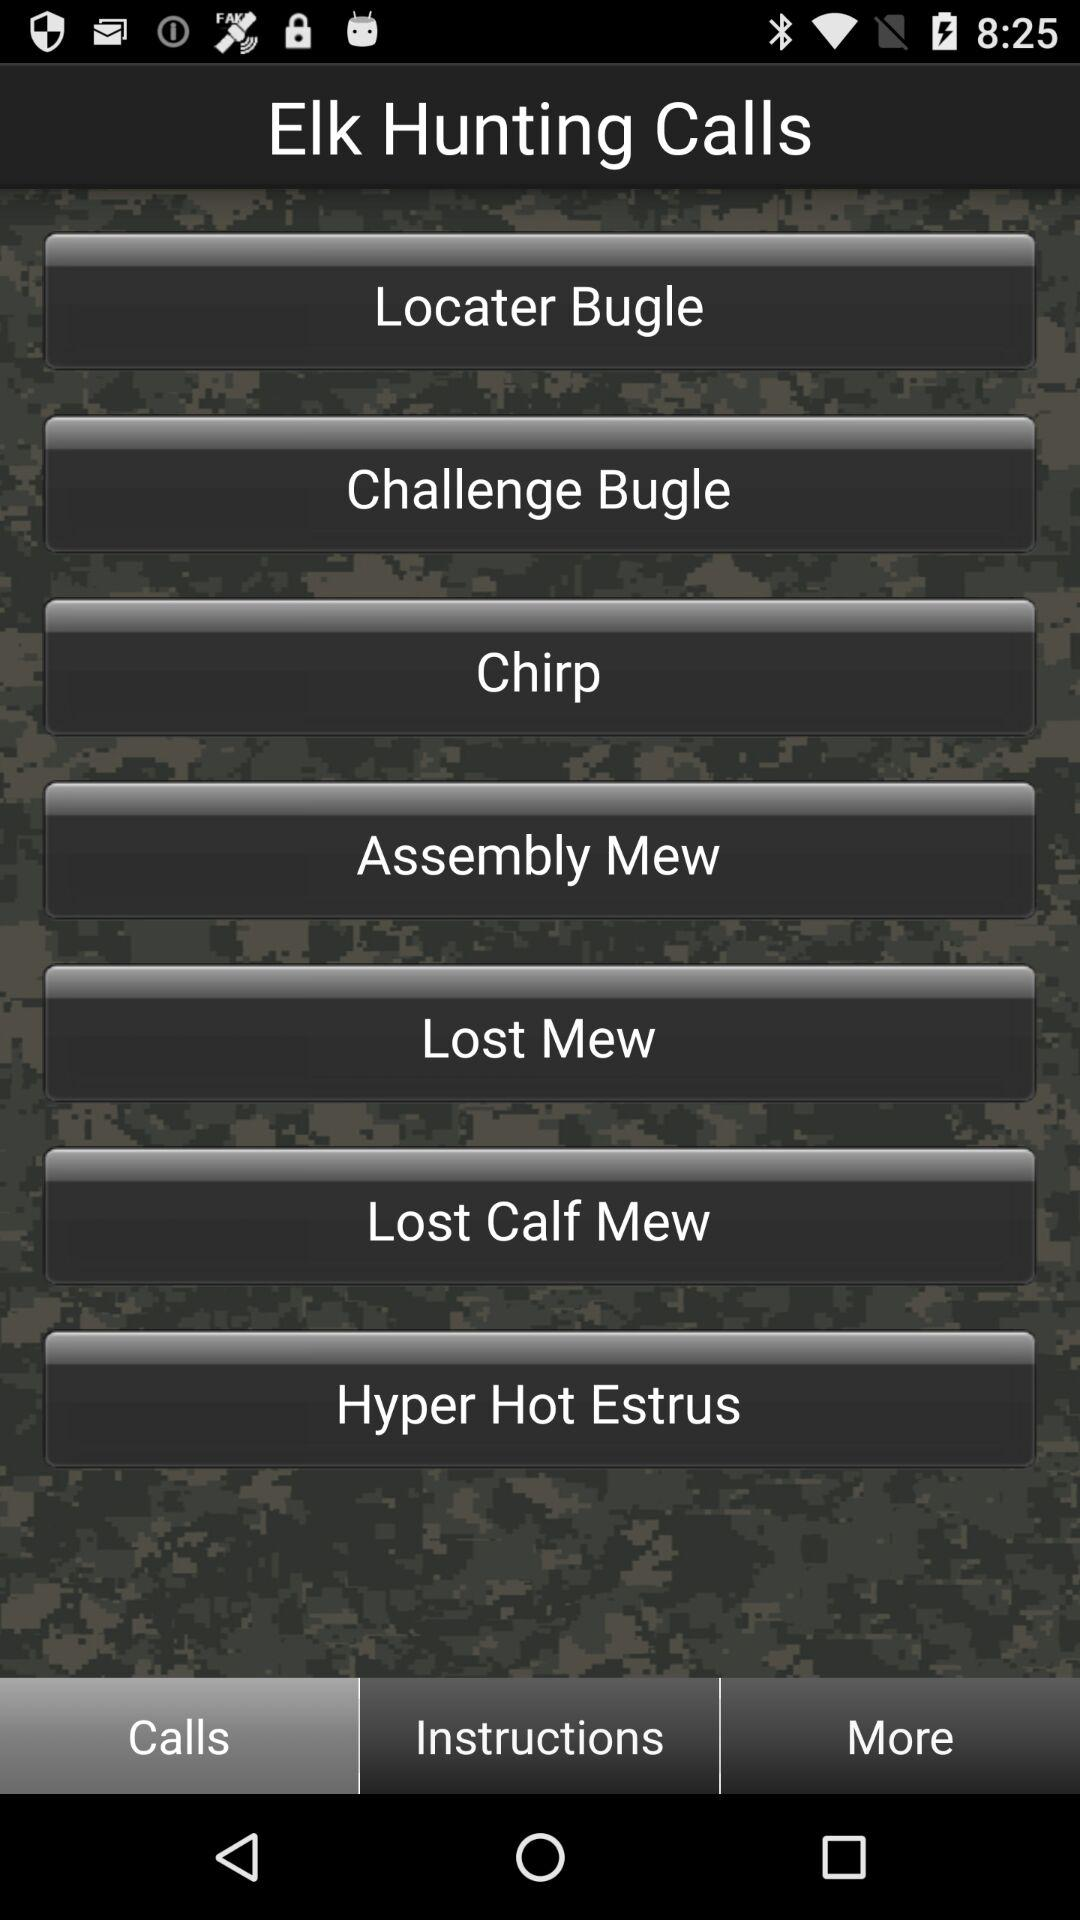What is the name of the application? The name of the application is "Elk Hunting Calls". 